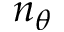<formula> <loc_0><loc_0><loc_500><loc_500>n _ { \theta }</formula> 